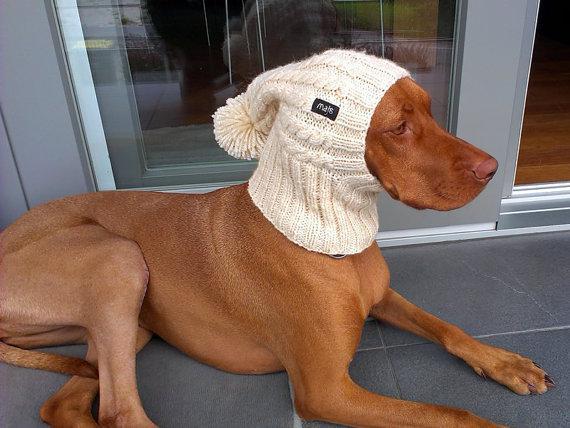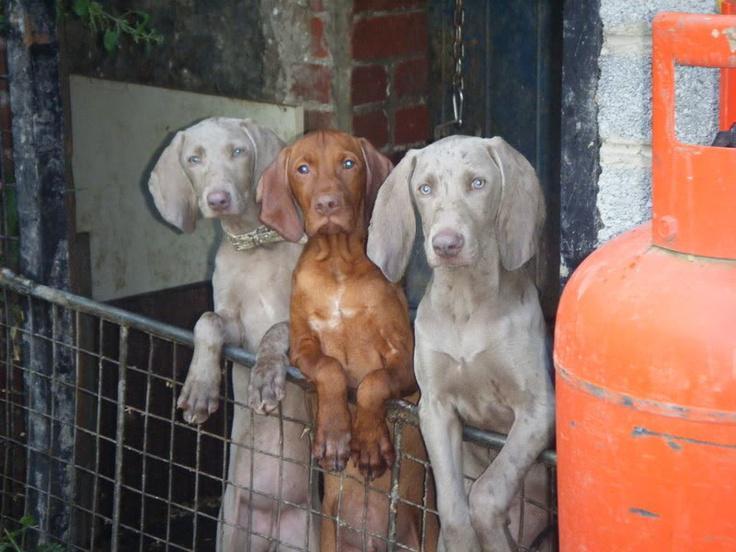The first image is the image on the left, the second image is the image on the right. For the images shown, is this caption "There are 3 dogs in one of the images and only 1 dog in the other image." true? Answer yes or no. Yes. 